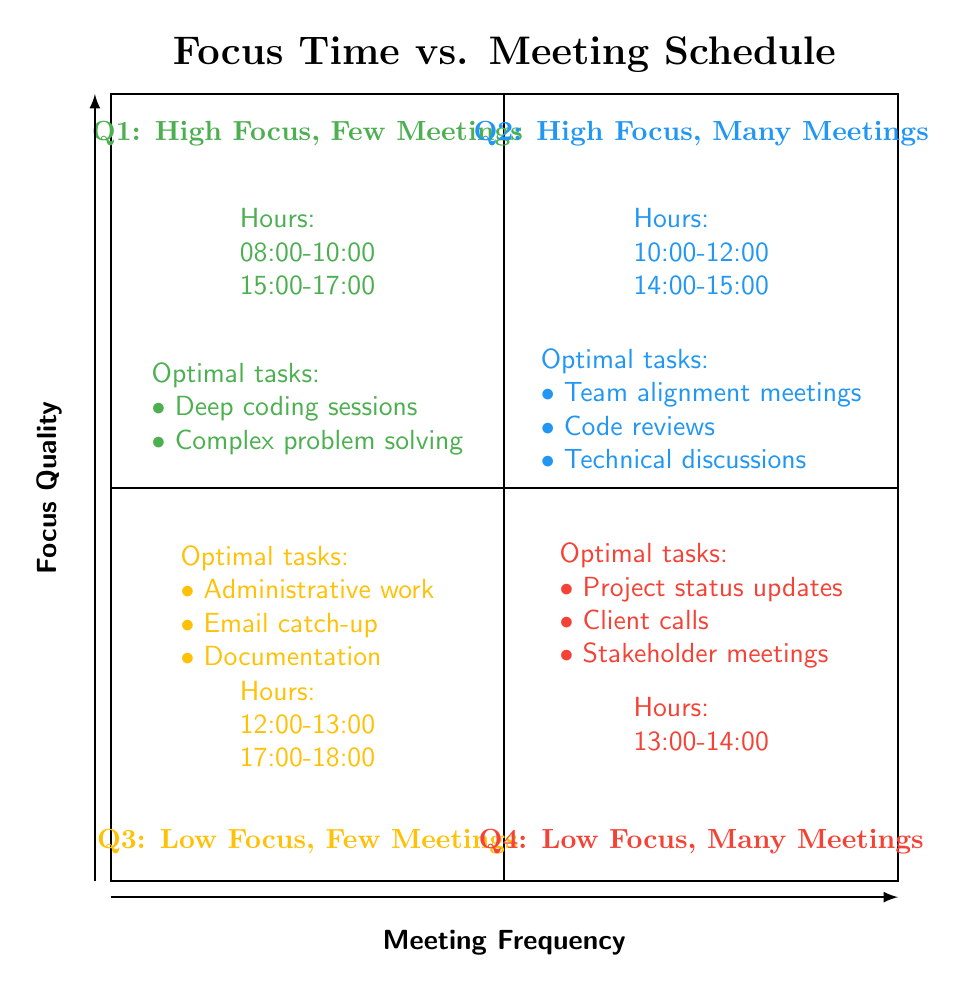What are the hours categorized in Q1? In quadrant Q1, the hours listed are "08:00-10:00" and "15:00-17:00", which indicate periods of high focus with few meetings.
Answer: 08:00-10:00, 15:00-17:00 Which quadrant has low focus and many meetings? Quadrant Q4 is described as having low focus and many meetings. It indicates a situation where scheduled meetings are prevalent, leading to decreased focus quality.
Answer: Q4 How many optimal tasks are in Q2? In quadrant Q2, there are three optimal tasks listed: team alignment meetings, code reviews, and technical discussions. Counting these provides the answer.
Answer: 3 What is the primary described focus quality in Q3? Q3 is characterized as "Low Focus, Few Meetings", indicating that while there are only a few meetings in this time frame, the quality of focus during these hours is also low.
Answer: Low Focus, Few Meetings Which quadrant is best for deep coding sessions? Q1 is identified as the optimal quadrant for performing deep coding sessions, as it is categorized by high focus levels and few meetings scheduled during those hours.
Answer: Q1 